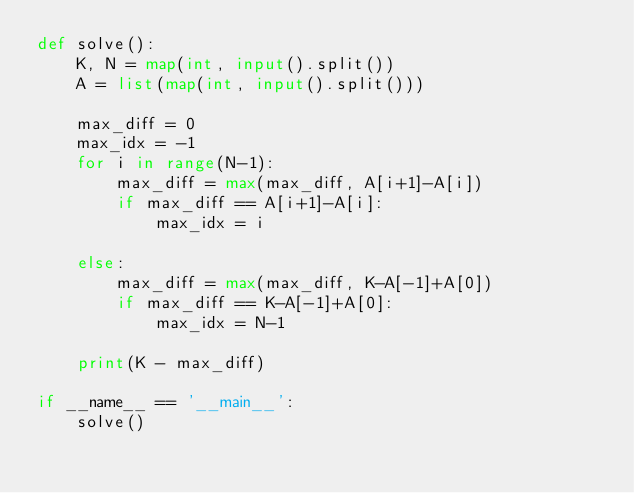Convert code to text. <code><loc_0><loc_0><loc_500><loc_500><_Python_>def solve():
    K, N = map(int, input().split())
    A = list(map(int, input().split()))

    max_diff = 0
    max_idx = -1
    for i in range(N-1):
        max_diff = max(max_diff, A[i+1]-A[i])
        if max_diff == A[i+1]-A[i]:
            max_idx = i
    
    else:
        max_diff = max(max_diff, K-A[-1]+A[0])
        if max_diff == K-A[-1]+A[0]:
            max_idx = N-1
    
    print(K - max_diff)

if __name__ == '__main__':
    solve()</code> 